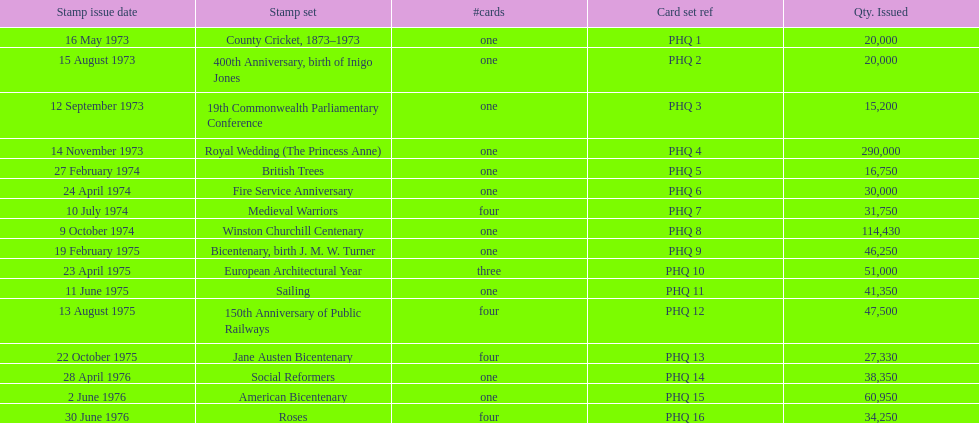Which was the only stamp set to have more than 200,000 issued? Royal Wedding (The Princess Anne). 